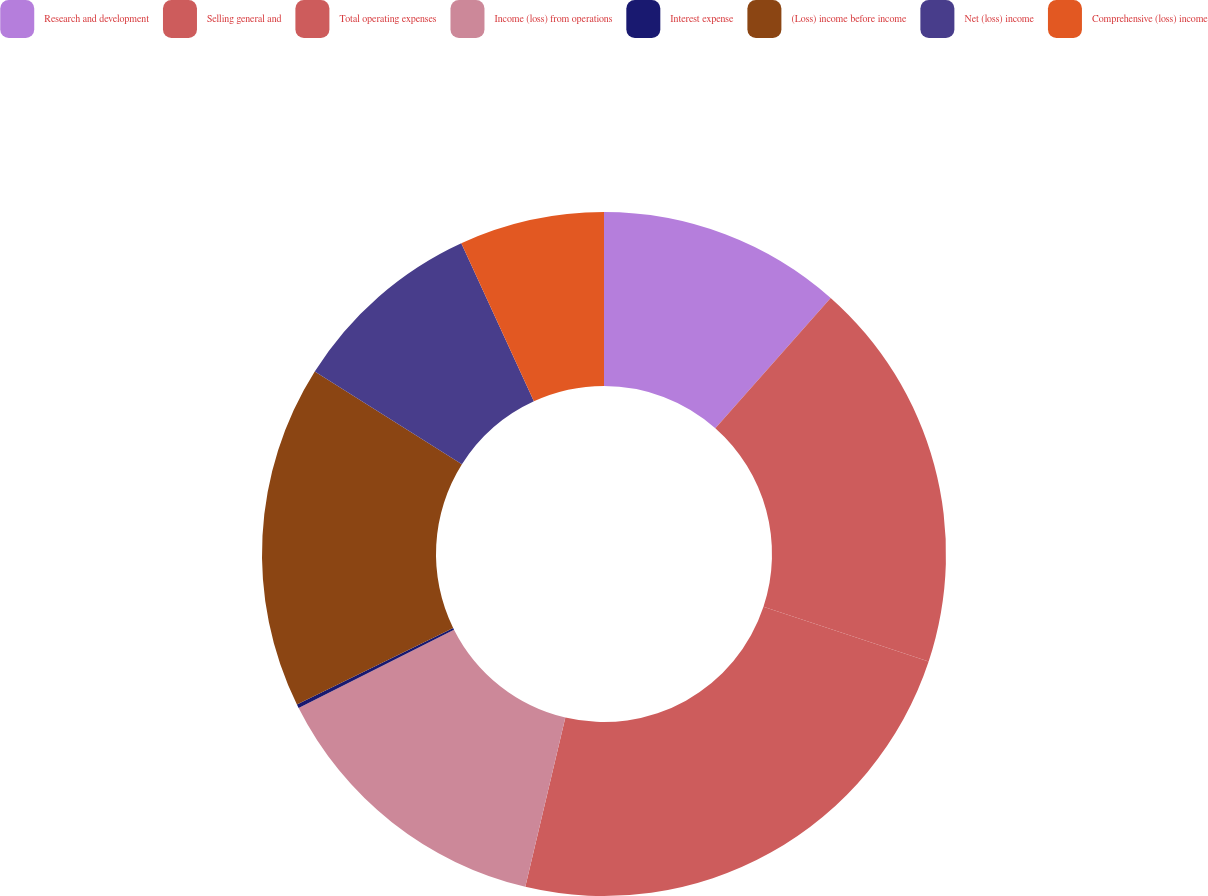Convert chart. <chart><loc_0><loc_0><loc_500><loc_500><pie_chart><fcel>Research and development<fcel>Selling general and<fcel>Total operating expenses<fcel>Income (loss) from operations<fcel>Interest expense<fcel>(Loss) income before income<fcel>Net (loss) income<fcel>Comprehensive (loss) income<nl><fcel>11.53%<fcel>18.56%<fcel>23.6%<fcel>13.87%<fcel>0.18%<fcel>16.21%<fcel>9.19%<fcel>6.85%<nl></chart> 